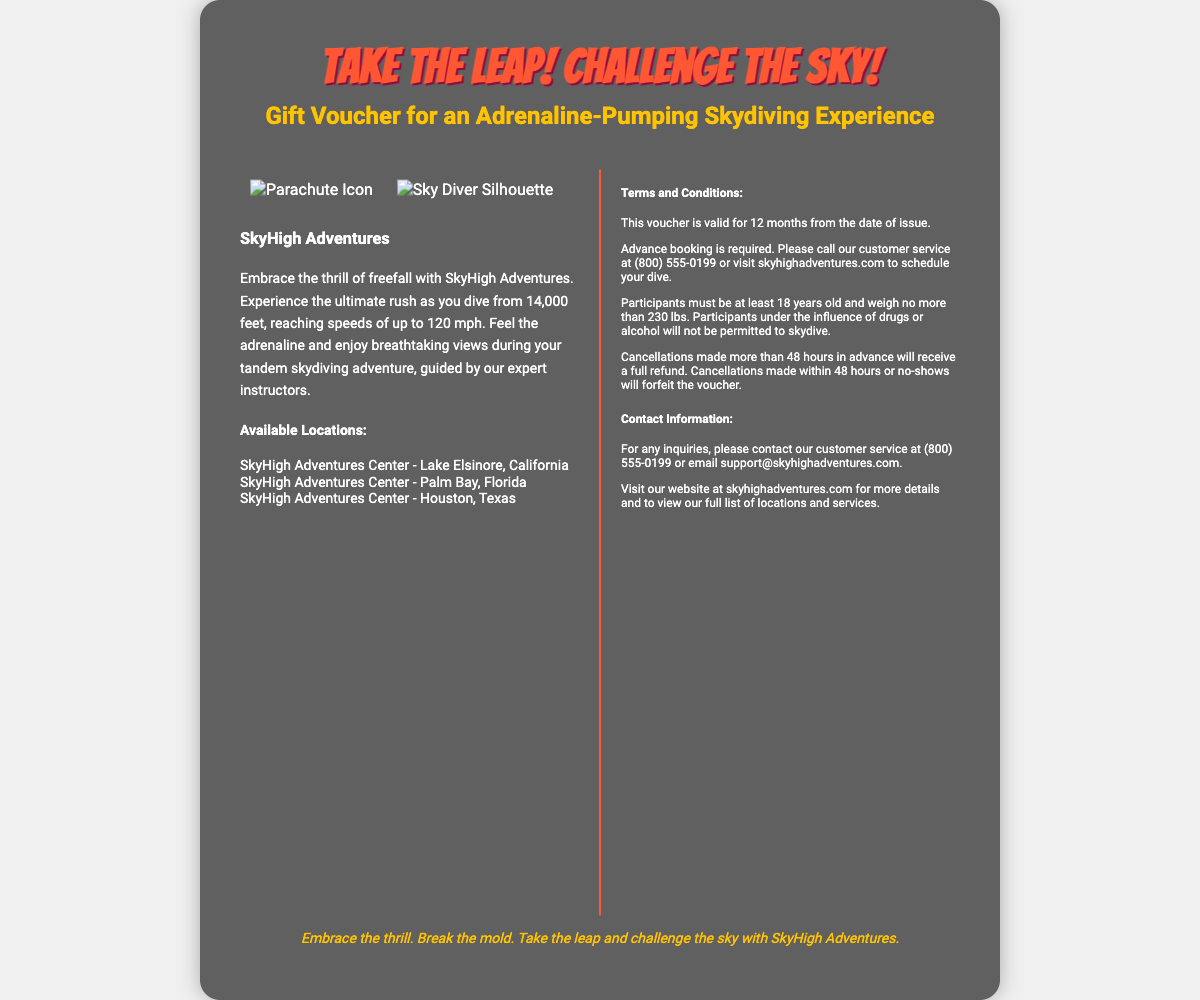What is the title of the voucher? The title of the voucher is prominently displayed at the top, stating "Take the Leap! Challenge the Sky!".
Answer: Take the Leap! Challenge the Sky! How many locations are mentioned for skydiving? The document lists three locations where the skydiving experience is available.
Answer: Three What is the minimum age requirement to participate? The document specifies that participants must be a certain age to skydive, which is stated as 18 years old.
Answer: 18 years What is the weight limit for participants? The voucher outlines the maximum weight participants can weigh, which is 230 lbs.
Answer: 230 lbs How long is the voucher valid? The validity period of the voucher is mentioned as lasting for a specific duration after issuance, which is 12 months.
Answer: 12 months What contact number should be used for inquiries? The document provides a specific customer service contact number for inquiries, which is stated as (800) 555-0199.
Answer: (800) 555-0199 What happens if a cancellation is made within 48 hours? The terms outline the consequences of late cancellations, indicating that they will forfeit the voucher.
Answer: Forfeit the voucher What experience does the voucher offer? The document clearly describes the type of experience provided by the voucher, which is a thrilling skydiving adventure.
Answer: Skydiving adventure What is the maximum speed during the dive? The document indicates the speed reached during the skydiving experience as a specific number.
Answer: 120 mph 